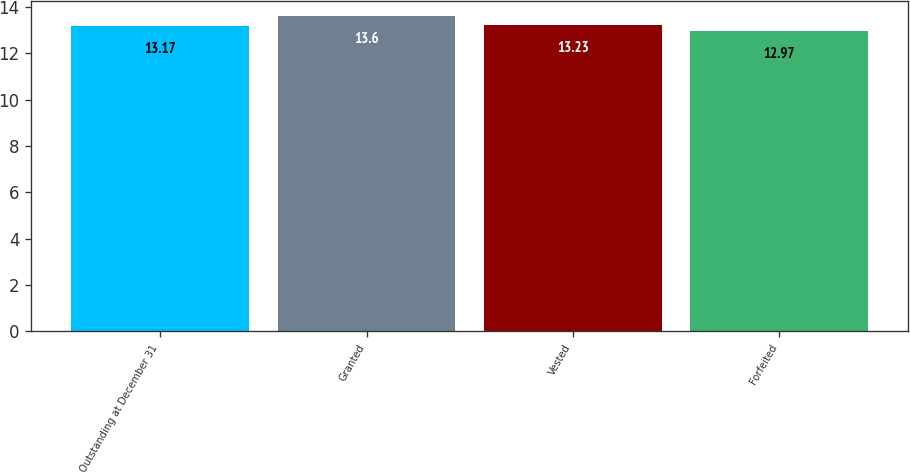<chart> <loc_0><loc_0><loc_500><loc_500><bar_chart><fcel>Outstanding at December 31<fcel>Granted<fcel>Vested<fcel>Forfeited<nl><fcel>13.17<fcel>13.6<fcel>13.23<fcel>12.97<nl></chart> 